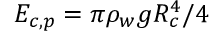Convert formula to latex. <formula><loc_0><loc_0><loc_500><loc_500>{ { E } _ { c , p } } = \pi { { \rho } _ { w } } g R _ { c } ^ { 4 } / 4</formula> 